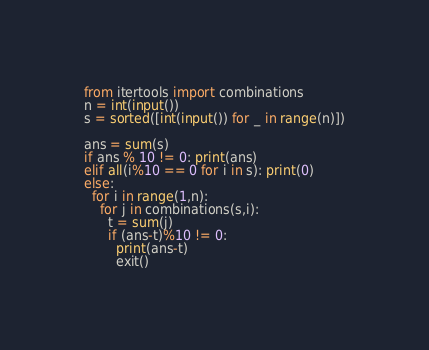<code> <loc_0><loc_0><loc_500><loc_500><_Python_>from itertools import combinations
n = int(input())
s = sorted([int(input()) for _ in range(n)])

ans = sum(s)
if ans % 10 != 0: print(ans)
elif all(i%10 == 0 for i in s): print(0)
else:
  for i in range(1,n):
    for j in combinations(s,i):
      t = sum(j)
      if (ans-t)%10 != 0:
        print(ans-t)
        exit()</code> 